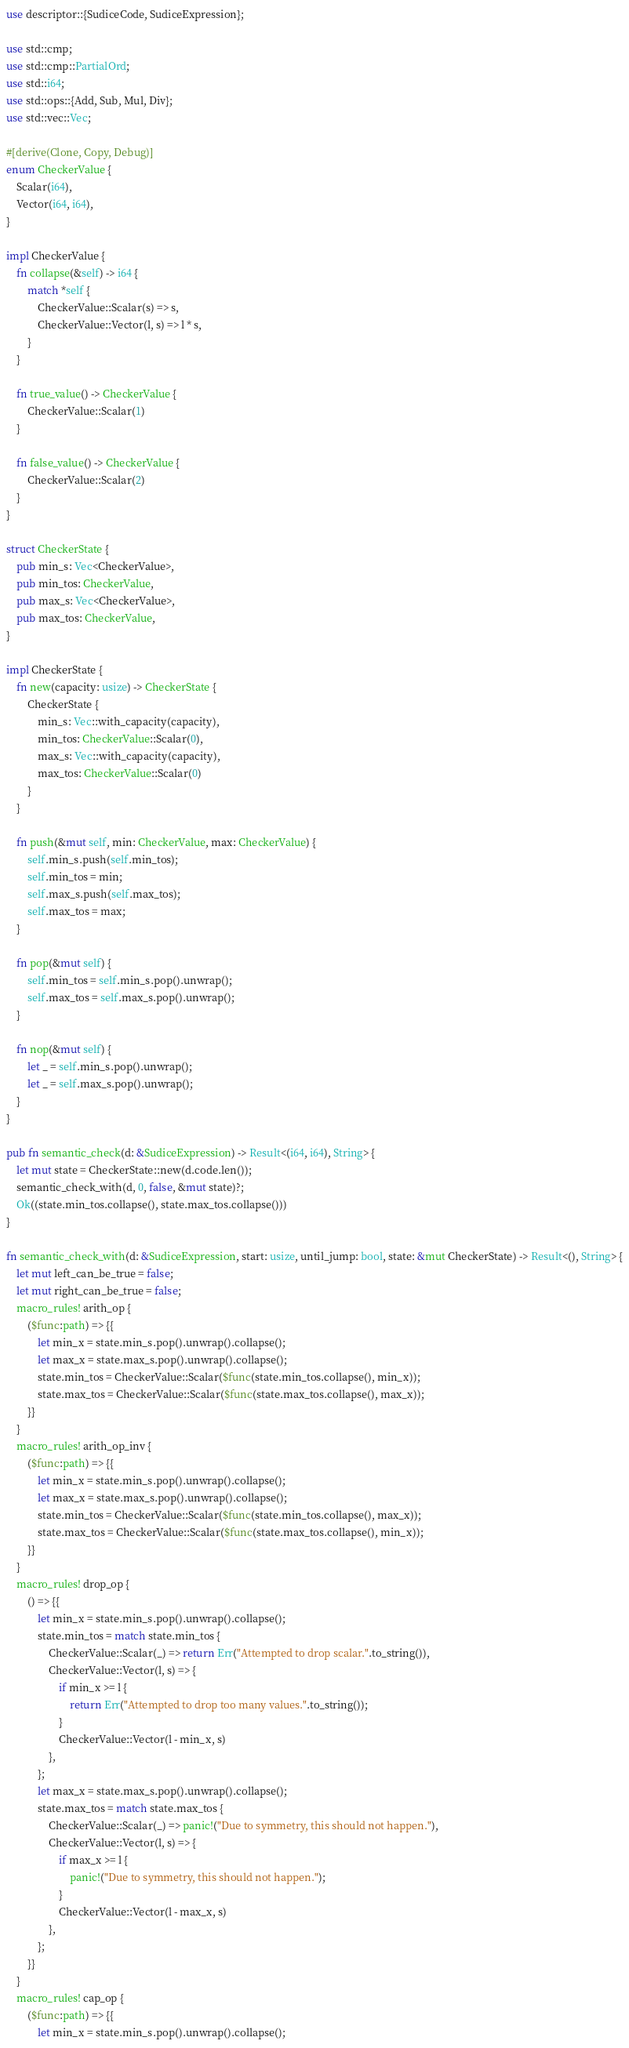<code> <loc_0><loc_0><loc_500><loc_500><_Rust_>use descriptor::{SudiceCode, SudiceExpression};

use std::cmp;
use std::cmp::PartialOrd;
use std::i64;
use std::ops::{Add, Sub, Mul, Div};
use std::vec::Vec;

#[derive(Clone, Copy, Debug)]
enum CheckerValue {
    Scalar(i64),
    Vector(i64, i64),
}

impl CheckerValue {
    fn collapse(&self) -> i64 {
        match *self {
            CheckerValue::Scalar(s) => s,
            CheckerValue::Vector(l, s) => l * s,
        }
    }

    fn true_value() -> CheckerValue {
        CheckerValue::Scalar(1)
    }

    fn false_value() -> CheckerValue {
        CheckerValue::Scalar(2)
    }
}

struct CheckerState {
    pub min_s: Vec<CheckerValue>,
    pub min_tos: CheckerValue,
    pub max_s: Vec<CheckerValue>,
    pub max_tos: CheckerValue,
}

impl CheckerState {
    fn new(capacity: usize) -> CheckerState {
        CheckerState {
            min_s: Vec::with_capacity(capacity),
            min_tos: CheckerValue::Scalar(0),
            max_s: Vec::with_capacity(capacity),
            max_tos: CheckerValue::Scalar(0)
        }
    }

    fn push(&mut self, min: CheckerValue, max: CheckerValue) {
        self.min_s.push(self.min_tos);
        self.min_tos = min;
        self.max_s.push(self.max_tos);
        self.max_tos = max;
    }

    fn pop(&mut self) {
        self.min_tos = self.min_s.pop().unwrap();
        self.max_tos = self.max_s.pop().unwrap();
    }

    fn nop(&mut self) {
        let _ = self.min_s.pop().unwrap();
        let _ = self.max_s.pop().unwrap();
    }
}

pub fn semantic_check(d: &SudiceExpression) -> Result<(i64, i64), String> {
    let mut state = CheckerState::new(d.code.len());
    semantic_check_with(d, 0, false, &mut state)?;
    Ok((state.min_tos.collapse(), state.max_tos.collapse()))
}

fn semantic_check_with(d: &SudiceExpression, start: usize, until_jump: bool, state: &mut CheckerState) -> Result<(), String> {
    let mut left_can_be_true = false;
    let mut right_can_be_true = false;
    macro_rules! arith_op {
        ($func:path) => {{
            let min_x = state.min_s.pop().unwrap().collapse();
            let max_x = state.max_s.pop().unwrap().collapse();
            state.min_tos = CheckerValue::Scalar($func(state.min_tos.collapse(), min_x));
            state.max_tos = CheckerValue::Scalar($func(state.max_tos.collapse(), max_x));
        }}
    }
    macro_rules! arith_op_inv {
        ($func:path) => {{
            let min_x = state.min_s.pop().unwrap().collapse();
            let max_x = state.max_s.pop().unwrap().collapse();
            state.min_tos = CheckerValue::Scalar($func(state.min_tos.collapse(), max_x));
            state.max_tos = CheckerValue::Scalar($func(state.max_tos.collapse(), min_x));
        }}
    }
    macro_rules! drop_op {
        () => {{
            let min_x = state.min_s.pop().unwrap().collapse();
            state.min_tos = match state.min_tos {
                CheckerValue::Scalar(_) => return Err("Attempted to drop scalar.".to_string()),
                CheckerValue::Vector(l, s) => {
                    if min_x >= l {
                        return Err("Attempted to drop too many values.".to_string());
                    }
                    CheckerValue::Vector(l - min_x, s)
                },
            };
            let max_x = state.max_s.pop().unwrap().collapse();
            state.max_tos = match state.max_tos {
                CheckerValue::Scalar(_) => panic!("Due to symmetry, this should not happen."),
                CheckerValue::Vector(l, s) => {
                    if max_x >= l {
                        panic!("Due to symmetry, this should not happen.");
                    }
                    CheckerValue::Vector(l - max_x, s)
                },
            };
        }}
    }
    macro_rules! cap_op {
        ($func:path) => {{
            let min_x = state.min_s.pop().unwrap().collapse();</code> 